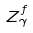Convert formula to latex. <formula><loc_0><loc_0><loc_500><loc_500>Z _ { \gamma } ^ { f }</formula> 